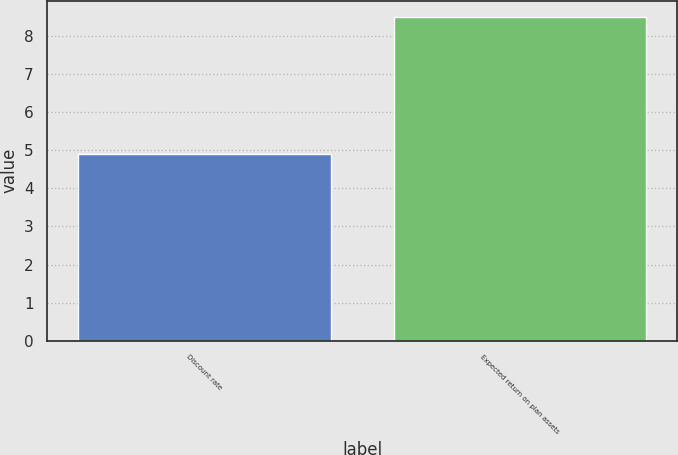Convert chart to OTSL. <chart><loc_0><loc_0><loc_500><loc_500><bar_chart><fcel>Discount rate<fcel>Expected return on plan assets<nl><fcel>4.89<fcel>8.5<nl></chart> 